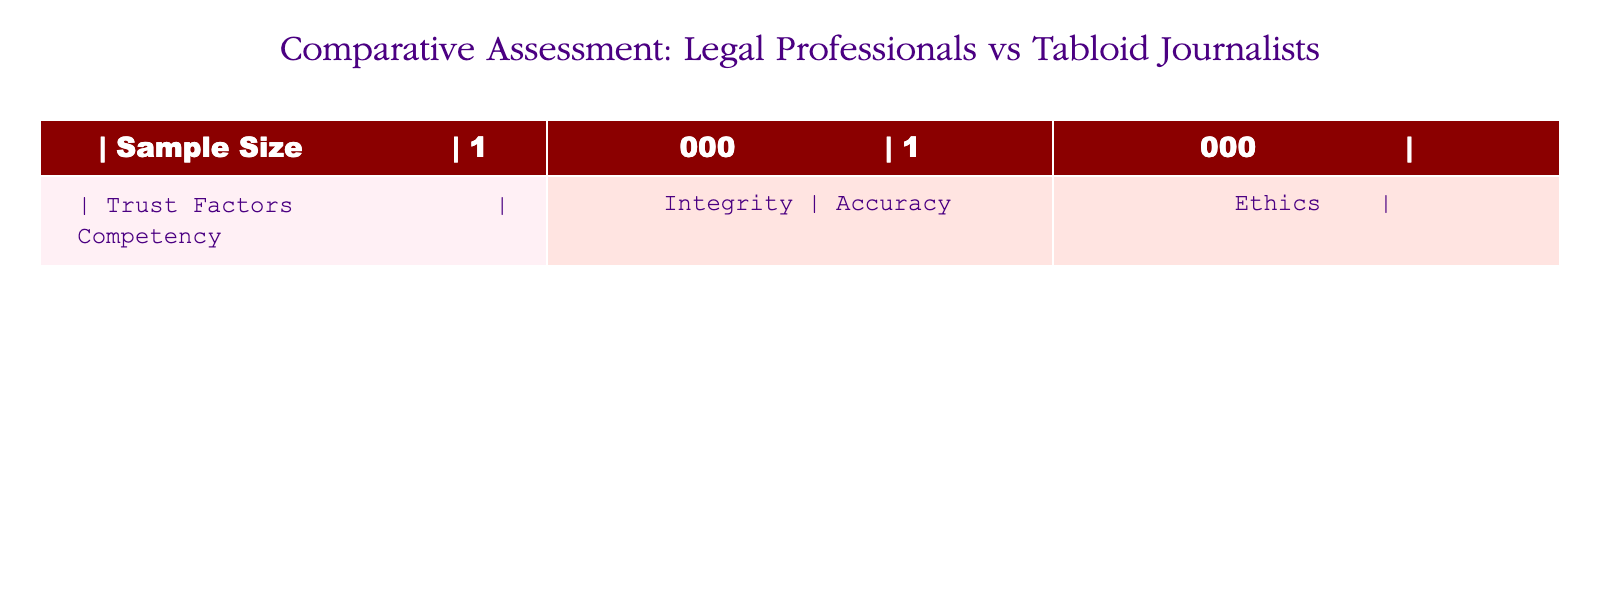What is the sample size for both legal professionals and tabloid journalists? The table lists the sample size twice as 1,000 for both categories, signifying that the number of respondents surveyed for each group is equal.
Answer: 1,000 What trust factors are considered for legal professionals? The table specifies "Competency" and "Integrity" as the trust factors attributed to legal professionals, indicating the qualities the public assesses in this group.
Answer: Competency, Integrity What is the trust factor for tabloid journalists labeled in the table? The table indicates that "Accuracy" and "Ethics" are the trust factors used to evaluate tabloid journalists, focusing on their reported qualities.
Answer: Accuracy, Ethics Is the sample size for legal professionals different from that of tabloid journalists? The table shows a sample size of 1,000 for both legal professionals and tabloid journalists, meaning the sample sizes are the same, therefore the answer is no.
Answer: No What is the primary difference in trust factors between legal professionals and tabloid journalists? The trust factors for legal professionals highlight "Competency" and "Integrity," while for tabloid journalists, it focuses on "Accuracy" and "Ethics." These distinctions denote different public perceptions of trust.
Answer: Competency and Integrity vs. Accuracy and Ethics If you were to average the trust factors listed for legal professionals and tabloid journalists, how would you summarize them? There are four unique trust factors: "Competency," "Integrity," "Accuracy," and "Ethics." While no numerical values are assigned to these factors, they categorize public trust in contrasting ways. The average is a conceptual summary of diverse expectations rather than a numeric average.
Answer: Competency, Integrity, Accuracy, Ethics Which set of trust factors is more focused on professional conduct? The trust factors for legal professionals focus on "Competency" and "Integrity," both of which reflect professional behavior and ethical standards inherent to legal practice, thus making them more indicative of professional conduct.
Answer: Legal professionals How do the concerns for tabloid journalists differ in the public's view compared to legal professionals? The table suggests that tabloid journalists are assessed based on "Accuracy" and "Ethics," indicating that public concern revolves around truthful reporting and moral standards, which contrasts with the professionalism emphasized for legal professionals.
Answer: Accuracy and Ethics vs. Competency and Integrity Is it true that both legal professionals and tabloid journalists have the same values as trust factors in recent surveys? The table lists distinct trust factors for each group, indicating that their assessed values differ and are not the same; thus the statement is false.
Answer: No 